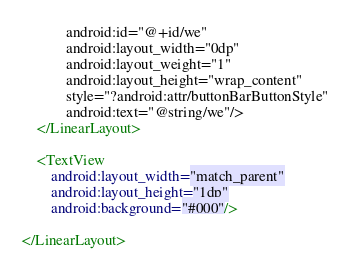<code> <loc_0><loc_0><loc_500><loc_500><_XML_>	        android:id="@+id/we"
	        android:layout_width="0dp"
	        android:layout_weight="1"
	        android:layout_height="wrap_content"
	        style="?android:attr/buttonBarButtonStyle"
	        android:text="@string/we"/>
    </LinearLayout>
    
    <TextView
        android:layout_width="match_parent"
        android:layout_height="1dp"
        android:background="#000"/>

</LinearLayout>
</code> 